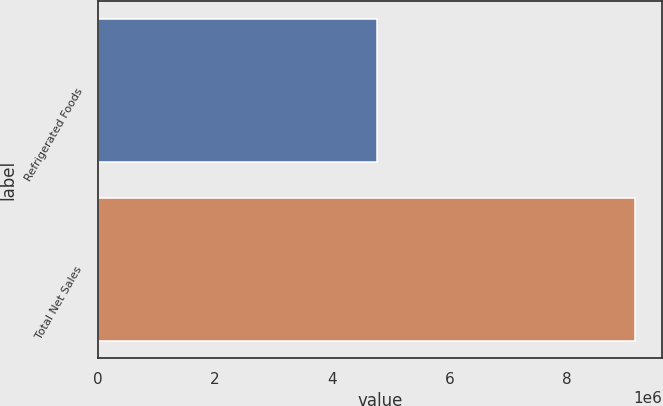Convert chart to OTSL. <chart><loc_0><loc_0><loc_500><loc_500><bar_chart><fcel>Refrigerated Foods<fcel>Total Net Sales<nl><fcel>4.75984e+06<fcel>9.16752e+06<nl></chart> 